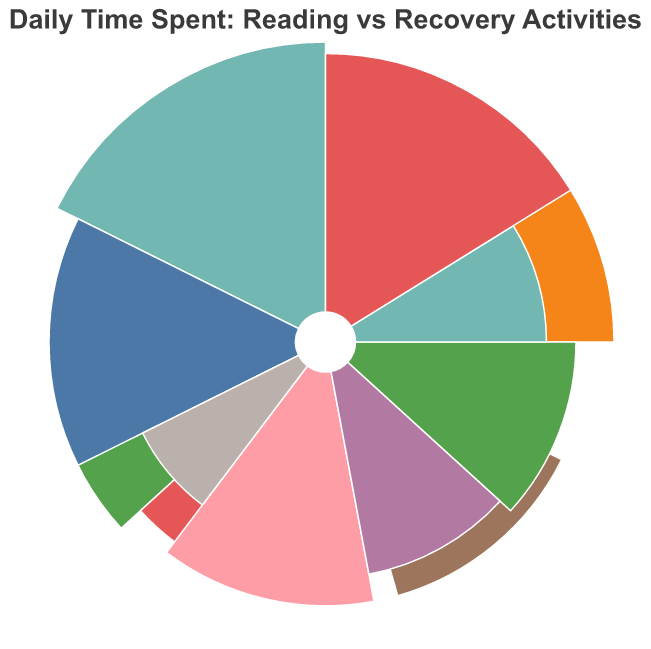What is the title of the figure? The title is usually prominently displayed at the top of the figure. It provides an overview of what the chart is about.
Answer: Daily Time Spent: Reading vs Recovery Activities How many data points are represented for books in the chart? Each book on the chart corresponds to a specific data point. By counting the number of different books listed, we can determine the total number of data points for books.
Answer: 8 Which book has the highest reading time? Look for the book title with the largest arc segment representing the "Reading Time (minutes)."
Answer: Crime and Punishment by Fyodor Dostoevsky Which recovery activity takes the most time? Look for the recovery activity with the largest arc segment representing "Recovery Activities Time (minutes)."
Answer: Therapy Sessions What is the total time spent on reading "1984 by George Orwell" and "The Catcher in the Rye by J.D. Salinger"? Sum the reading times for both books. "1984 by George Orwell" has 30 minutes and "The Catcher in the Rye by J.D. Salinger" has 20 minutes. 30 + 20 = 50 minutes.
Answer: 50 minutes What is the difference in time spent on "Meditation Exercises" and "Journaling"? Subtract the time spent on "Journaling" from the time spent on "Meditation Exercises." "Meditation Exercises" has 40 minutes, "Journaling" has 30 minutes. 40 - 30 = 10 minutes.
Answer: 10 minutes Which has more time associated with it on average, reading time or recovery activities time? Calculate the average time for both categories and compare them. The sum of reading times: 45 + 30 + 50 + 40 + 25 + 35 + 55 + 20 = 300 minutes. The sum of recovery activities times: 60 + 50 + 40 + 30 + 45 + 35 + 25 + 55 = 340 minutes. Averages are 300/8 = 37.5 minutes for reading and 340/8 = 42.5 minutes for recovery activities.
Answer: Recovery activities time Which recovery activity is paired with the least reading time? Find the recovery activity associated with the book having the smallest arc segment for "Reading Time (minutes)."
Answer: Educational Workshops What is the total combined time for "War and Peace" and its paired recovery activity? Sum the reading time and the recovery activity time for "War and Peace by Leo Tolstoy". Reading time = 35 minutes, Recovery activities time = 35 minutes. 35 + 35 = 70 minutes.
Answer: 70 minutes Is there a book for which the associated reading time and recovery time are equal? Look for any book and recovery activity pair where the reading time and recovery activities time values match.
Answer: War and Peace by Leo Tolstoy 